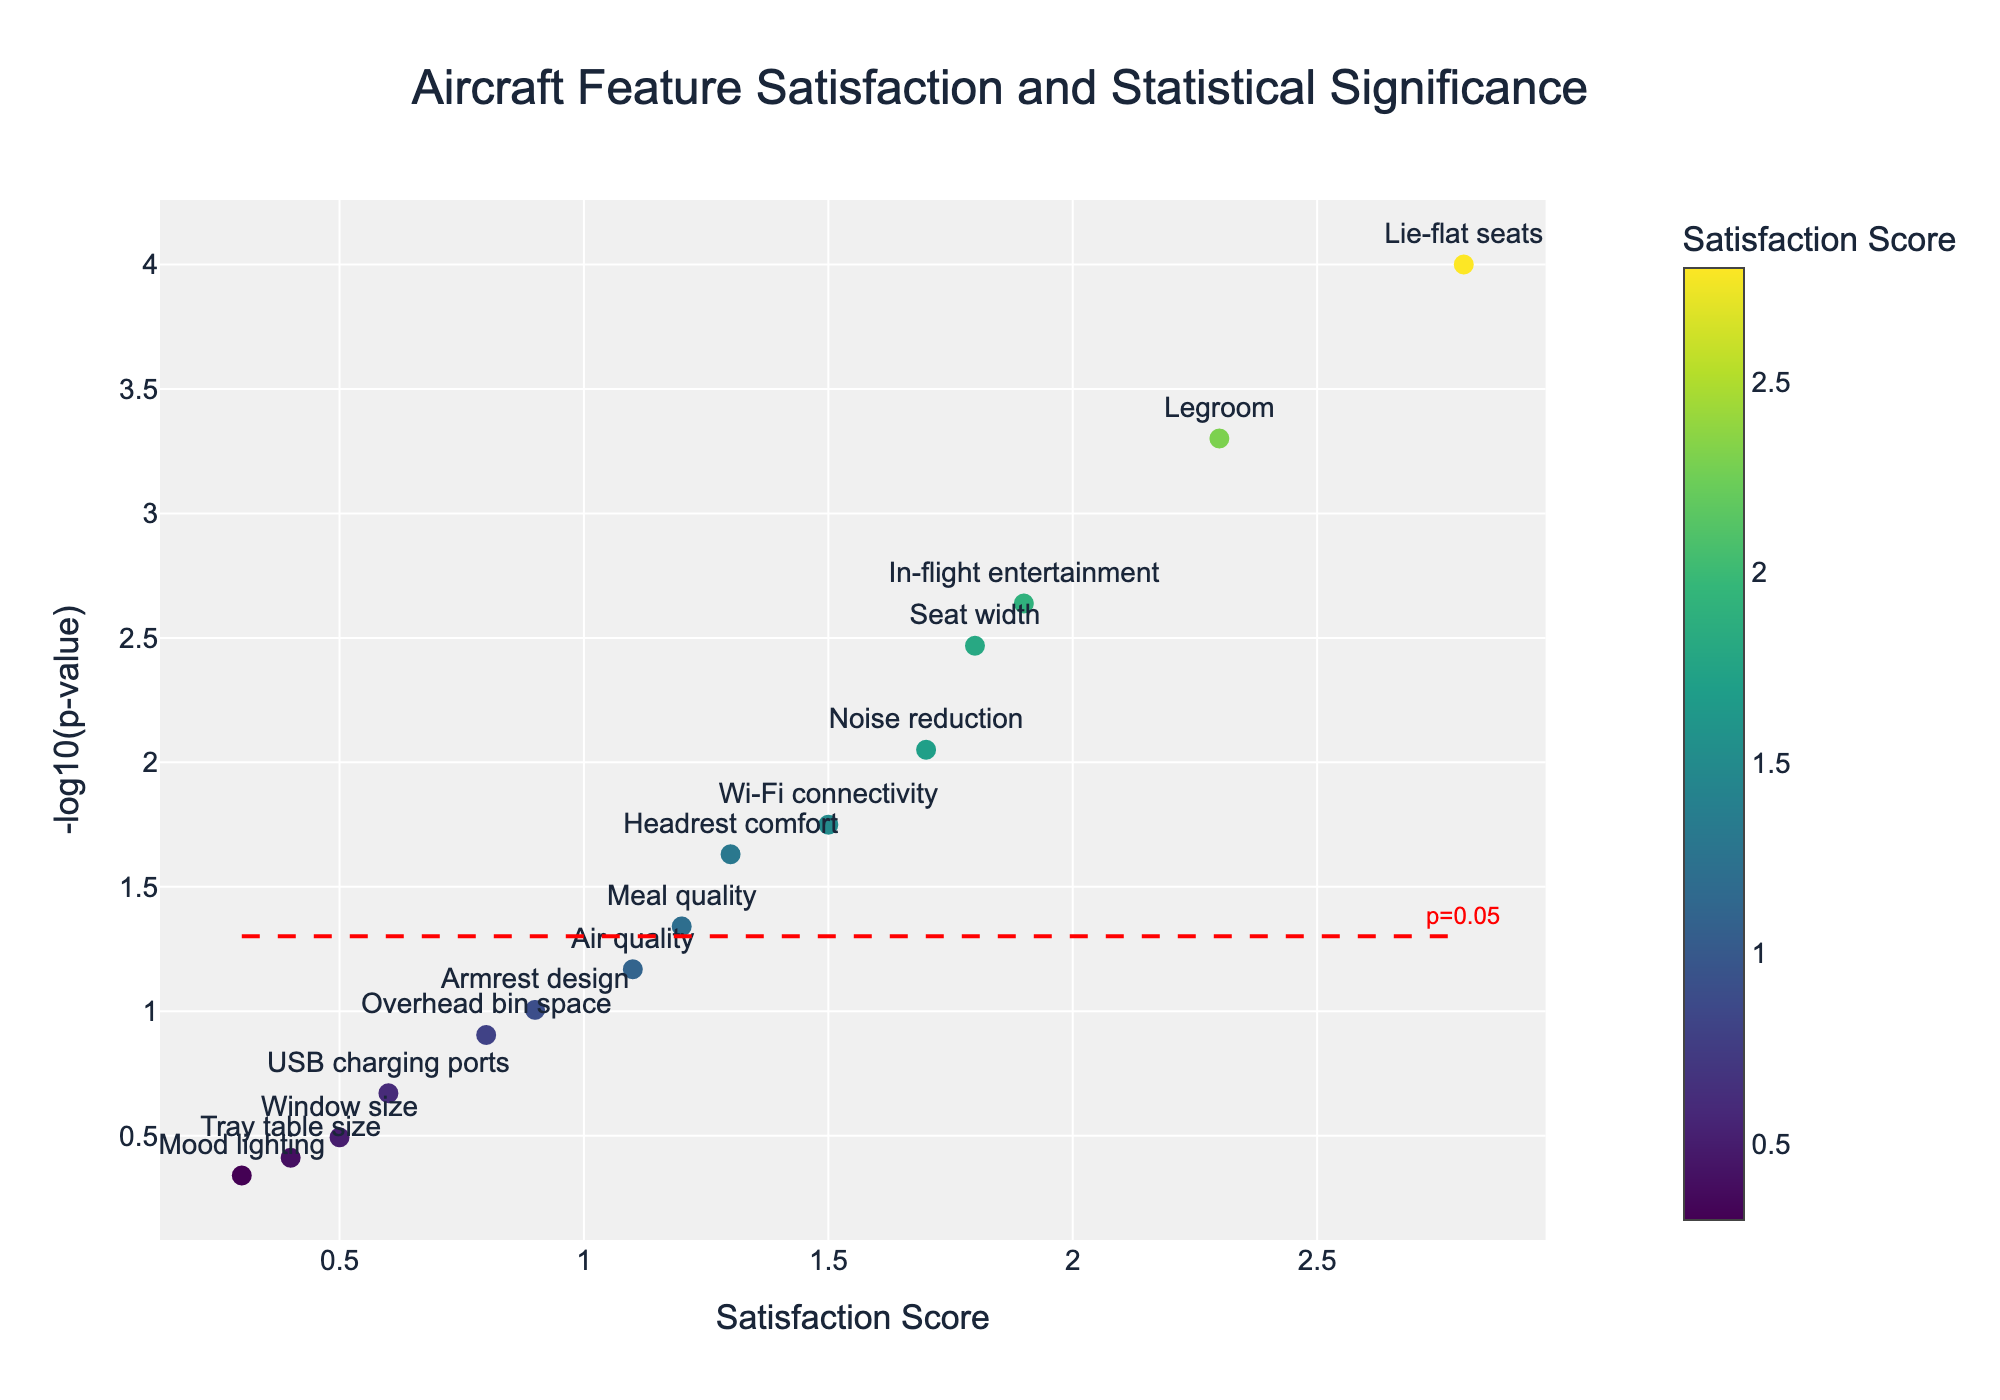What is the title of the plot? The title is located at the top center of the plot and is labeled 'Aircraft Feature Satisfaction and Statistical Significance'.
Answer: Aircraft Feature Satisfaction and Statistical Significance How many features have statistical significance with a p-value below 0.05? The p-value threshold is indicated by a red dashed horizontal line. Identify how many features are above this line.
Answer: Eight features Which feature has the highest satisfaction score? Locate the feature with the highest x-axis value representing the satisfaction score.
Answer: Lie-flat seats What is the satisfaction score for USB charging ports? Find USB charging ports on the plot and record its x-axis value representing the satisfaction score.
Answer: 0.6 Which feature has the lowest p-value? Locate the feature with the highest y-axis value representing -log10(p-value), as a smaller p-value corresponds to a higher -log10(p-value).
Answer: Lie-flat seats Which feature has the lowest satisfaction score but still has a statistically significant p-value? Identify the features above the red dashed line and find the one with the lowest x-axis value (satisfaction score).
Answer: Wi-Fi connectivity How many features have a satisfaction score above 1.5? Count the number of features with x-axis values greater than 1.5.
Answer: Six features Which feature, if any, lies closest to the horizontal dashed line representing p=0.05? Find the feature whose y-axis value (log10(p-value)) is closest to the red dashed line.
Answer: Air quality Compare the statistical significance of 'Legroom' and 'Seat width'. Which one is more significant? Compare the y-axis values of Legroom and Seat width, higher values indicate more statistical significance.
Answer: Legroom 